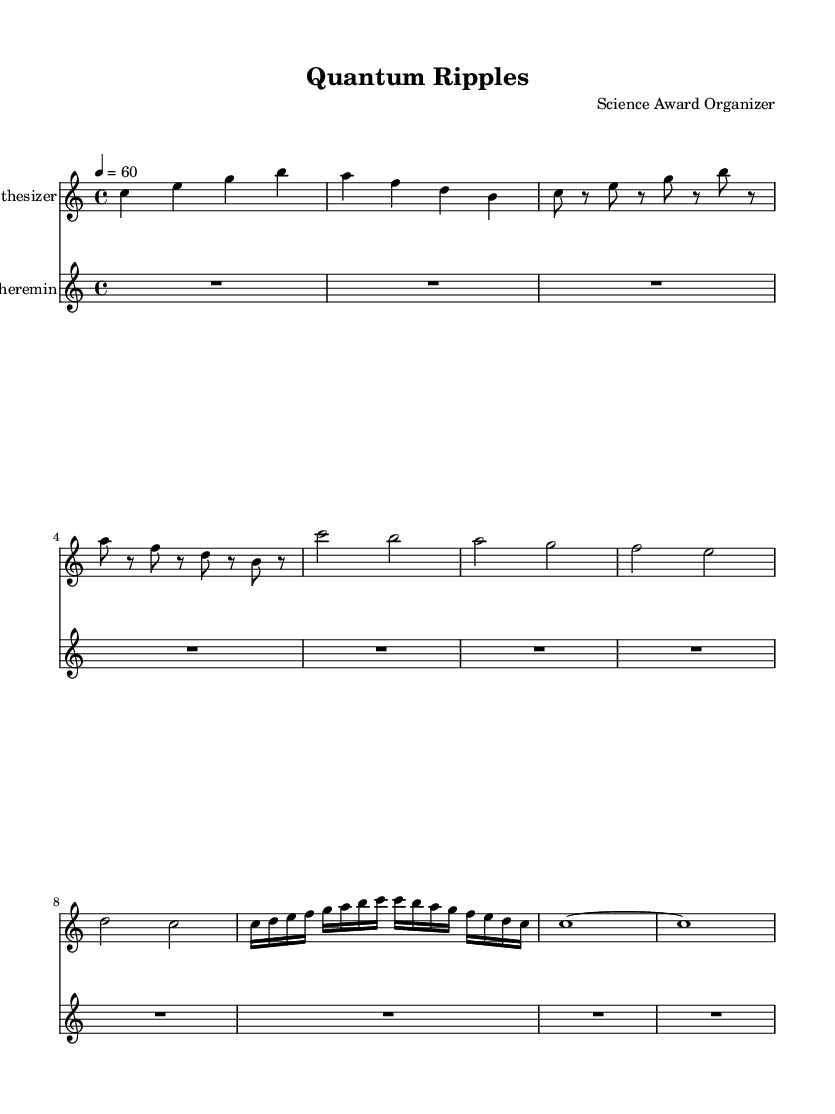What is the key signature of this music? The key signature is indicated by the absence of any sharps or flats, establishing it as C major.
Answer: C major What is the time signature of this music? The time signature is placed at the beginning of the score and is written as 4/4, indicating four beats in a measure.
Answer: 4/4 What is the tempo marking for this composition? The tempo is specified at the beginning and is indicated as 4 = 60, which means there are 60 quarter-note beats per minute.
Answer: 60 How many measures are in the verse section? By counting the measures in the verse part of the synthesizer line, there are a total of four measures noted.
Answer: 4 What type of instrument is the theremin in this piece? The theremin is indicated in the score as a separate staff, and it is recognized as an electronic instrument known for its unique sound.
Answer: Electronic instrument What is the significance of the use of rests in the theremin part? The rests in the theremin part serve as a placeholder, implying that the actual sounds and notations are produced dynamically rather than being fixed, which is common in experimental music.
Answer: Placeholder Which section follows the chorus in this composition? The score indicates a bridge section immediately follows the chorus, characterized by rapid notes leading back into a different thematic material.
Answer: Bridge 